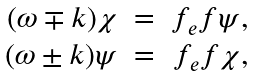Convert formula to latex. <formula><loc_0><loc_0><loc_500><loc_500>\begin{array} { r c r } { ( \omega \mp k ) \chi } & { = } & { { f _ { e } f \psi , } } \\ { ( \omega \pm k ) \psi } & { = } & { { f _ { e } f \chi , } } \end{array}</formula> 